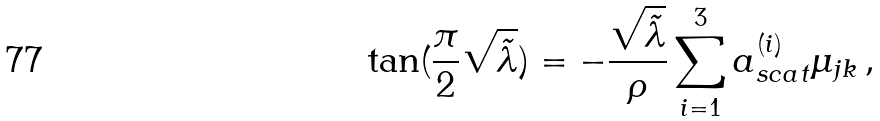Convert formula to latex. <formula><loc_0><loc_0><loc_500><loc_500>\tan ( \frac { \pi } { 2 } \sqrt { \tilde { \lambda } } ) = - \frac { \sqrt { \tilde { \lambda } } } { \rho } \sum _ { i = 1 } ^ { 3 } a _ { s c a t } ^ { ( i ) } \mu _ { j k } \, ,</formula> 